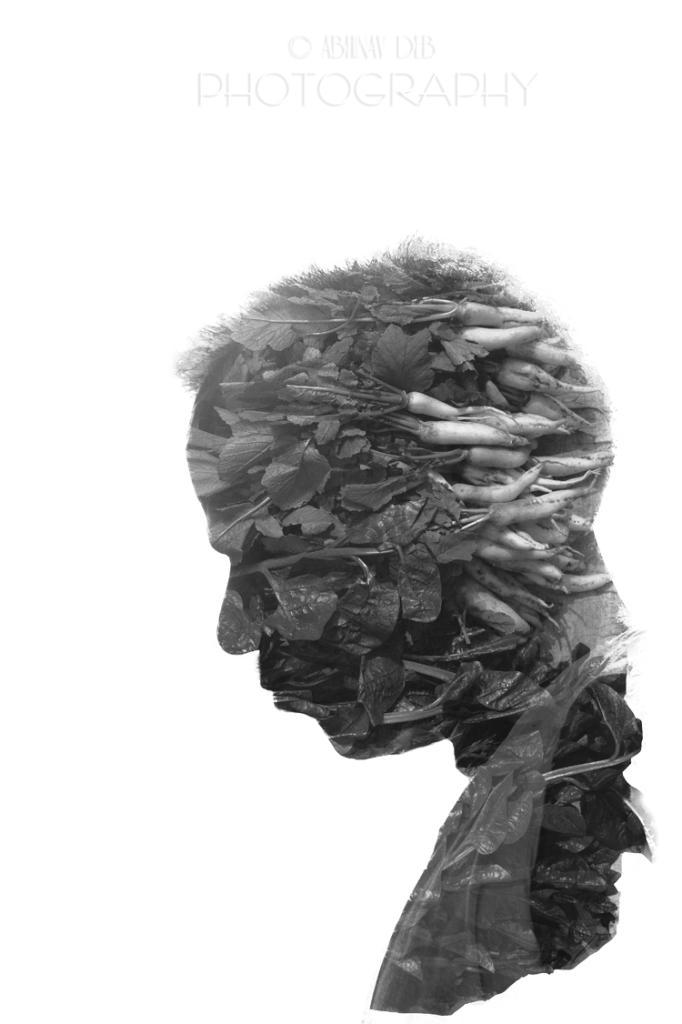Who is present in the image? There is a man in the image. What is the man doing with the vegetables? The man is using vegetables in the image. What can be seen at the top of the image? There is text written at the top of the image. What type of lace can be seen on the man's collar in the image? There is no lace or collar visible on the man in the image. Where is the playground located in the image? There is no playground present in the image. 